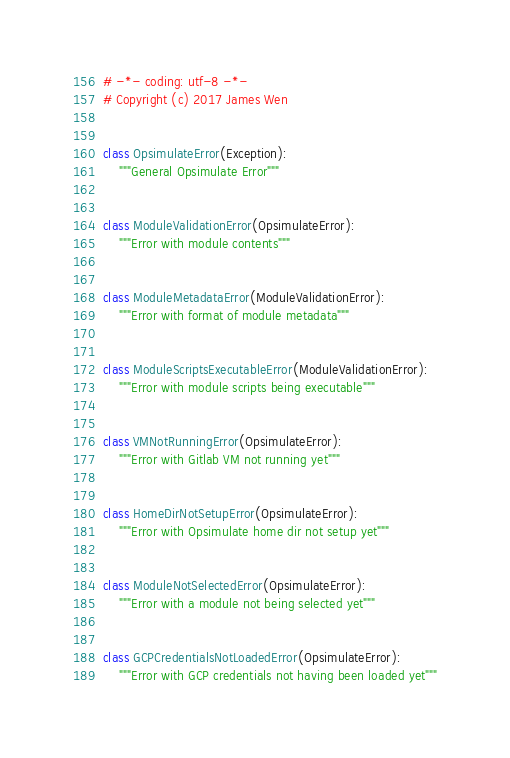Convert code to text. <code><loc_0><loc_0><loc_500><loc_500><_Python_># -*- coding: utf-8 -*-
# Copyright (c) 2017 James Wen


class OpsimulateError(Exception):
    """General Opsimulate Error"""


class ModuleValidationError(OpsimulateError):
    """Error with module contents"""


class ModuleMetadataError(ModuleValidationError):
    """Error with format of module metadata"""


class ModuleScriptsExecutableError(ModuleValidationError):
    """Error with module scripts being executable"""


class VMNotRunningError(OpsimulateError):
    """Error with Gitlab VM not running yet"""


class HomeDirNotSetupError(OpsimulateError):
    """Error with Opsimulate home dir not setup yet"""


class ModuleNotSelectedError(OpsimulateError):
    """Error with a module not being selected yet"""


class GCPCredentialsNotLoadedError(OpsimulateError):
    """Error with GCP credentials not having been loaded yet"""
</code> 